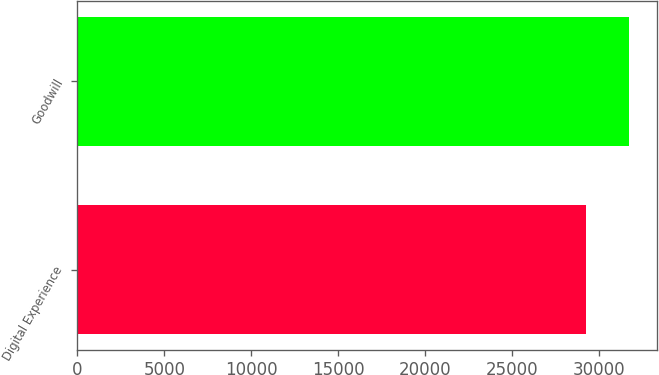Convert chart. <chart><loc_0><loc_0><loc_500><loc_500><bar_chart><fcel>Digital Experience<fcel>Goodwill<nl><fcel>29246<fcel>31729<nl></chart> 